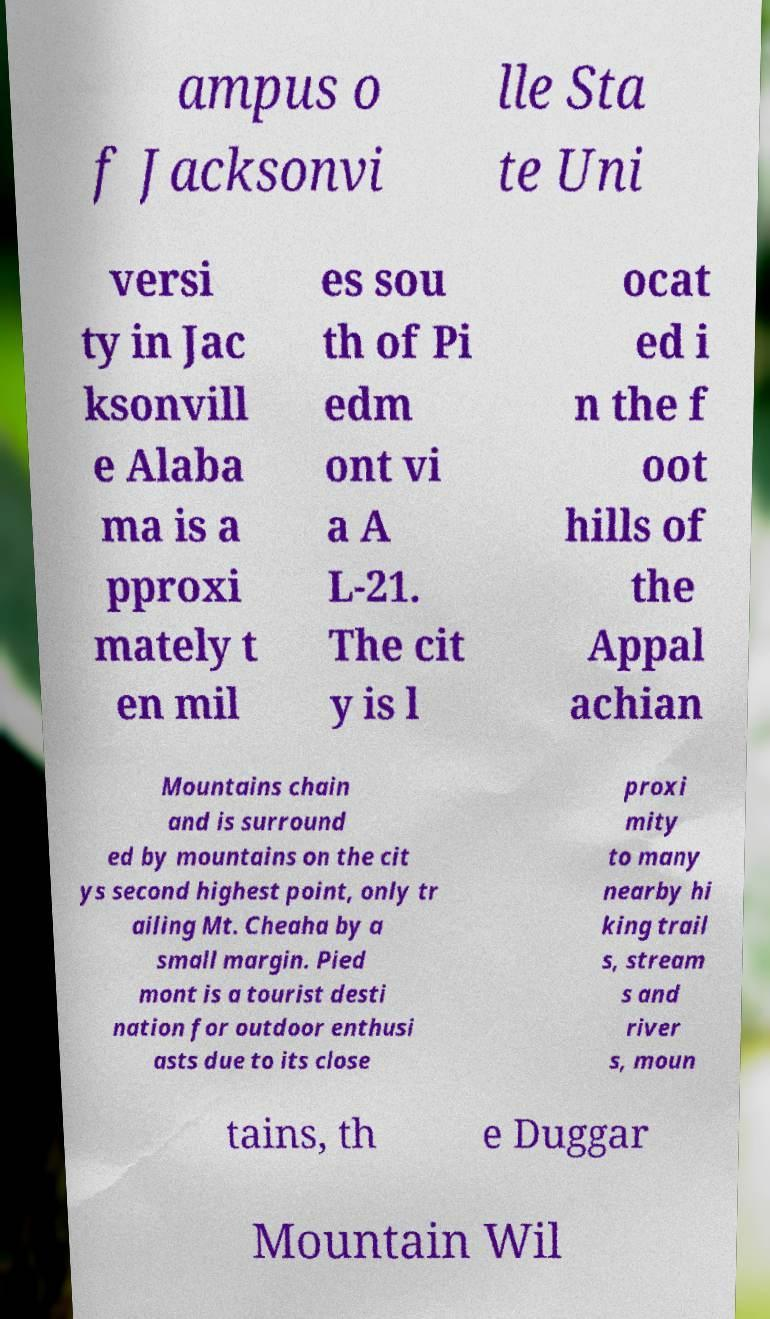Please identify and transcribe the text found in this image. ampus o f Jacksonvi lle Sta te Uni versi ty in Jac ksonvill e Alaba ma is a pproxi mately t en mil es sou th of Pi edm ont vi a A L-21. The cit y is l ocat ed i n the f oot hills of the Appal achian Mountains chain and is surround ed by mountains on the cit ys second highest point, only tr ailing Mt. Cheaha by a small margin. Pied mont is a tourist desti nation for outdoor enthusi asts due to its close proxi mity to many nearby hi king trail s, stream s and river s, moun tains, th e Duggar Mountain Wil 